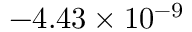Convert formula to latex. <formula><loc_0><loc_0><loc_500><loc_500>- 4 . 4 3 \times 1 0 ^ { - 9 }</formula> 